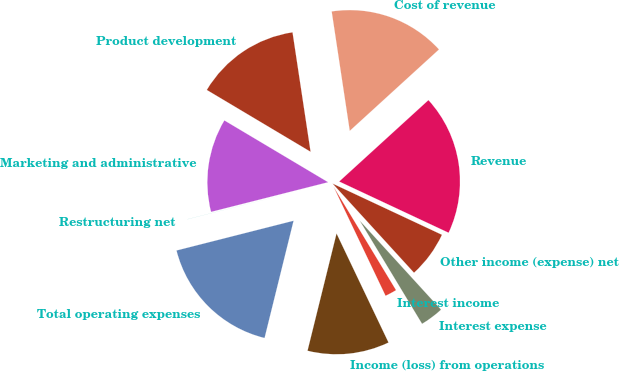Convert chart to OTSL. <chart><loc_0><loc_0><loc_500><loc_500><pie_chart><fcel>Revenue<fcel>Cost of revenue<fcel>Product development<fcel>Marketing and administrative<fcel>Restructuring net<fcel>Total operating expenses<fcel>Income (loss) from operations<fcel>Interest income<fcel>Interest expense<fcel>Other income (expense) net<nl><fcel>18.74%<fcel>15.62%<fcel>14.06%<fcel>12.5%<fcel>0.01%<fcel>17.18%<fcel>10.94%<fcel>1.57%<fcel>3.13%<fcel>6.25%<nl></chart> 